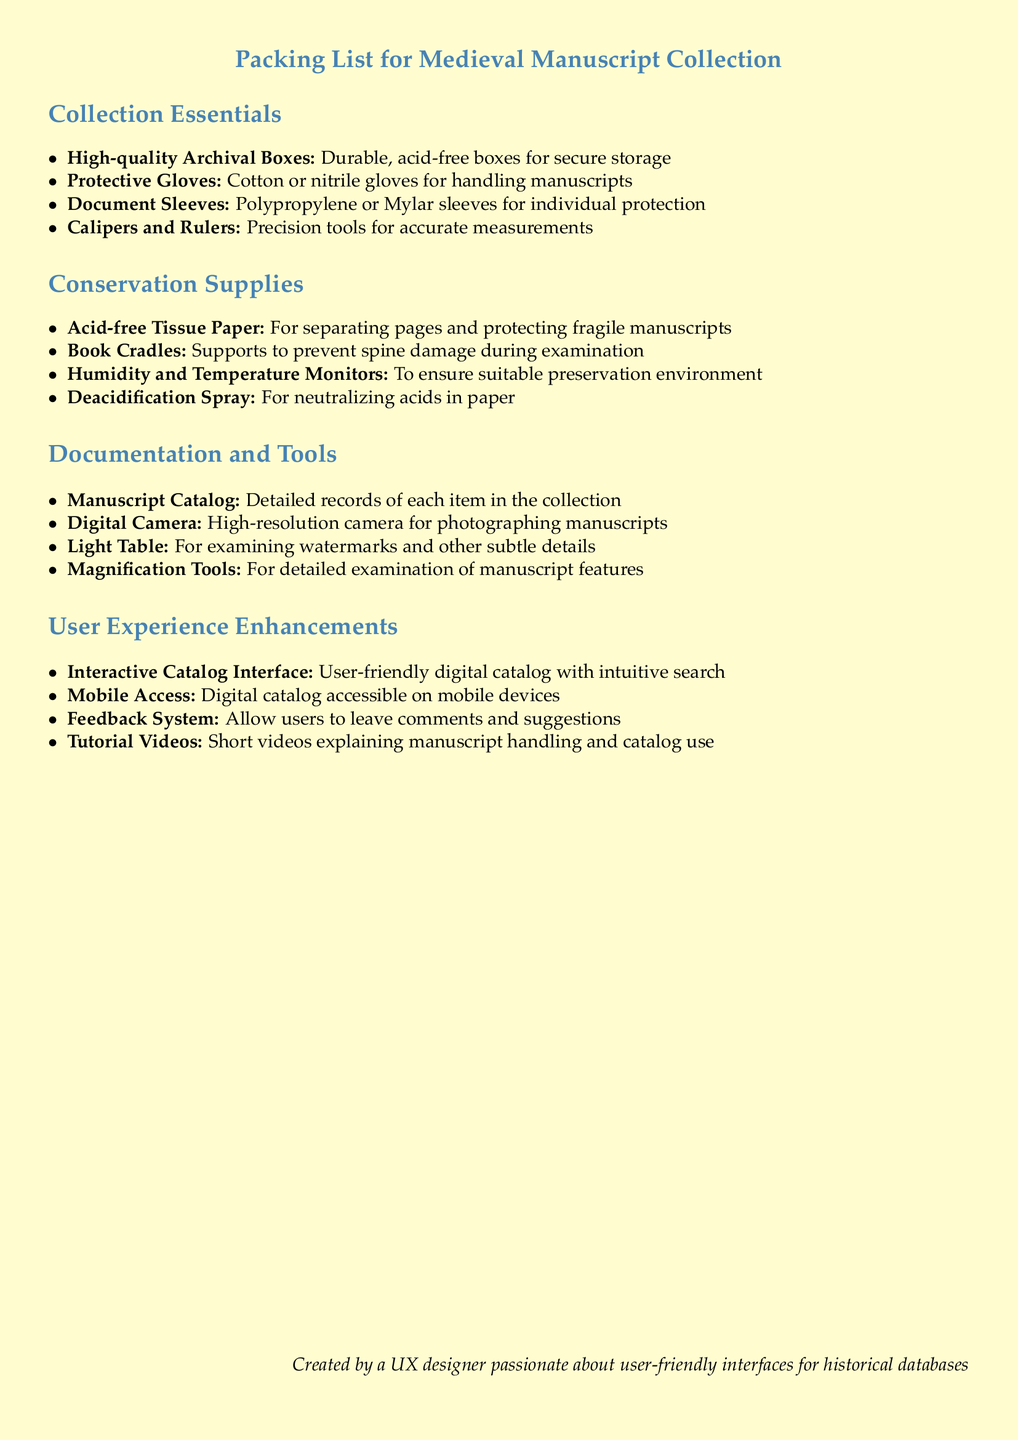What is the color of the protective gloves? The document specifies the type of gloves but does not mention a color. It states that cotton or nitrile gloves are to be used.
Answer: cotton or nitrile How many sections are there in the packing list? The document contains four main sections: Collection Essentials, Conservation Supplies, Documentation and Tools, and User Experience Enhancements.
Answer: four What is listed under User Experience Enhancements? This section lists several enhancements aimed at improving user experience, including an interactive catalog interface, mobile access, a feedback system, and tutorial videos.
Answer: Interactive Catalog Interface, Mobile Access, Feedback System, Tutorial Videos What tool is suggested for measuring manuscripts? The packing list mentions the use of calipers and rulers for accurate measurements of manuscripts.
Answer: Calipers and Rulers Which document is suggested for maintaining records of the collection? The packing list emphasizes the importance of a manuscript catalog for keeping detailed records of each item in the collection.
Answer: Manuscript Catalog 